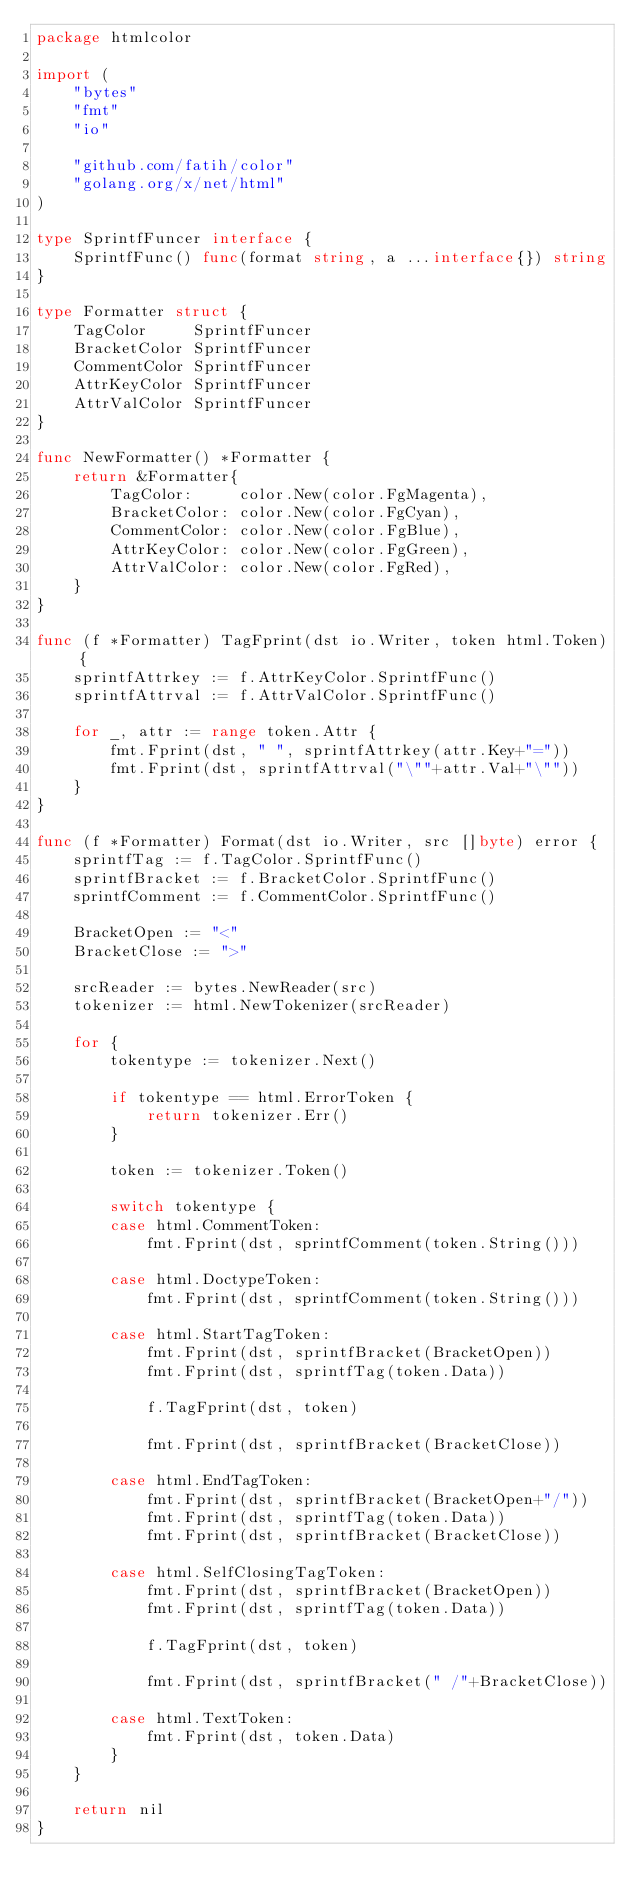Convert code to text. <code><loc_0><loc_0><loc_500><loc_500><_Go_>package htmlcolor

import (
	"bytes"
	"fmt"
	"io"

	"github.com/fatih/color"
	"golang.org/x/net/html"
)

type SprintfFuncer interface {
	SprintfFunc() func(format string, a ...interface{}) string
}

type Formatter struct {
	TagColor     SprintfFuncer
	BracketColor SprintfFuncer
	CommentColor SprintfFuncer
	AttrKeyColor SprintfFuncer
	AttrValColor SprintfFuncer
}

func NewFormatter() *Formatter {
	return &Formatter{
		TagColor:     color.New(color.FgMagenta),
		BracketColor: color.New(color.FgCyan),
		CommentColor: color.New(color.FgBlue),
		AttrKeyColor: color.New(color.FgGreen),
		AttrValColor: color.New(color.FgRed),
	}
}

func (f *Formatter) TagFprint(dst io.Writer, token html.Token) {
	sprintfAttrkey := f.AttrKeyColor.SprintfFunc()
	sprintfAttrval := f.AttrValColor.SprintfFunc()

	for _, attr := range token.Attr {
		fmt.Fprint(dst, " ", sprintfAttrkey(attr.Key+"="))
		fmt.Fprint(dst, sprintfAttrval("\""+attr.Val+"\""))
	}
}

func (f *Formatter) Format(dst io.Writer, src []byte) error {
	sprintfTag := f.TagColor.SprintfFunc()
	sprintfBracket := f.BracketColor.SprintfFunc()
	sprintfComment := f.CommentColor.SprintfFunc()

	BracketOpen := "<"
	BracketClose := ">"

	srcReader := bytes.NewReader(src)
	tokenizer := html.NewTokenizer(srcReader)

	for {
		tokentype := tokenizer.Next()

		if tokentype == html.ErrorToken {
			return tokenizer.Err()
		}

		token := tokenizer.Token()

		switch tokentype {
		case html.CommentToken:
			fmt.Fprint(dst, sprintfComment(token.String()))

		case html.DoctypeToken:
			fmt.Fprint(dst, sprintfComment(token.String()))

		case html.StartTagToken:
			fmt.Fprint(dst, sprintfBracket(BracketOpen))
			fmt.Fprint(dst, sprintfTag(token.Data))

			f.TagFprint(dst, token)

			fmt.Fprint(dst, sprintfBracket(BracketClose))

		case html.EndTagToken:
			fmt.Fprint(dst, sprintfBracket(BracketOpen+"/"))
			fmt.Fprint(dst, sprintfTag(token.Data))
			fmt.Fprint(dst, sprintfBracket(BracketClose))

		case html.SelfClosingTagToken:
			fmt.Fprint(dst, sprintfBracket(BracketOpen))
			fmt.Fprint(dst, sprintfTag(token.Data))

			f.TagFprint(dst, token)

			fmt.Fprint(dst, sprintfBracket(" /"+BracketClose))

		case html.TextToken:
			fmt.Fprint(dst, token.Data)
		}
	}

	return nil
}
</code> 